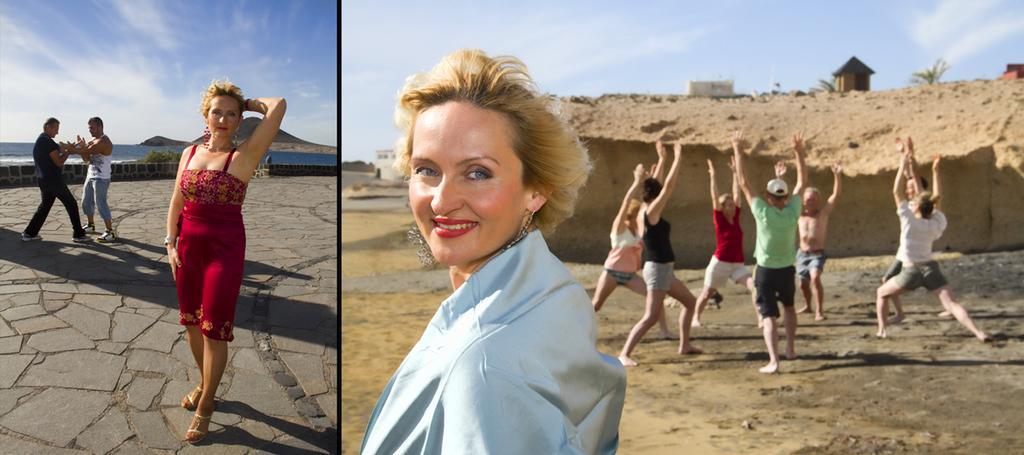Could you give a brief overview of what you see in this image? This is a collage. On the first image a lady is standing. Behind her two persons are standing. In the background there is water, hill and sky. On the second image there is a lady standing and smiling. In the back some people are standing. In the background there is a wall. On that there is a hut and sky is in the background. 